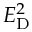<formula> <loc_0><loc_0><loc_500><loc_500>E _ { D } ^ { 2 }</formula> 